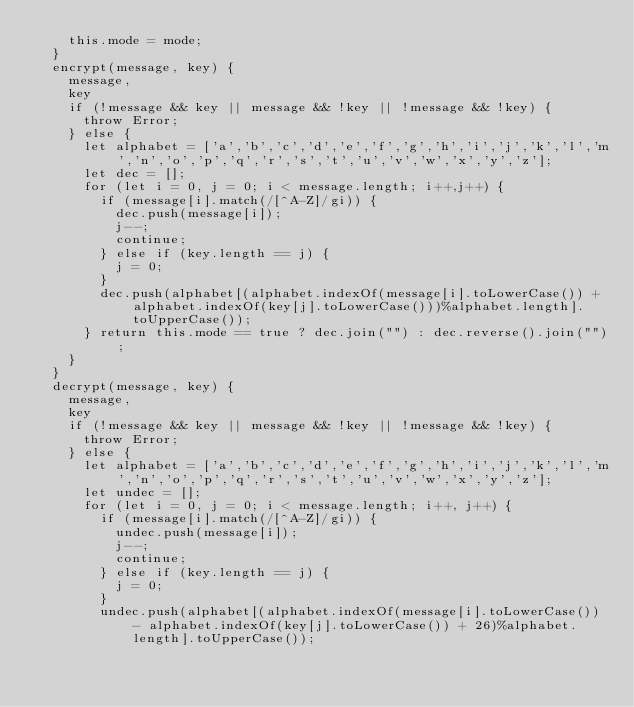Convert code to text. <code><loc_0><loc_0><loc_500><loc_500><_JavaScript_>    this.mode = mode;
  }
  encrypt(message, key) {
    message,
    key
    if (!message && key || message && !key || !message && !key) {
      throw Error;
    } else {
      let alphabet = ['a','b','c','d','e','f','g','h','i','j','k','l','m','n','o','p','q','r','s','t','u','v','w','x','y','z'];
      let dec = [];
      for (let i = 0, j = 0; i < message.length; i++,j++) {
        if (message[i].match(/[^A-Z]/gi)) {
          dec.push(message[i]);
          j--;
          continue;
        } else if (key.length == j) {
          j = 0;
        }
        dec.push(alphabet[(alphabet.indexOf(message[i].toLowerCase()) + alphabet.indexOf(key[j].toLowerCase()))%alphabet.length].toUpperCase());
      } return this.mode == true ? dec.join("") : dec.reverse().join("");
    } 
  }   
  decrypt(message, key) {
    message,
    key
    if (!message && key || message && !key || !message && !key) {
      throw Error;
    } else {
      let alphabet = ['a','b','c','d','e','f','g','h','i','j','k','l','m','n','o','p','q','r','s','t','u','v','w','x','y','z'];
      let undec = [];
      for (let i = 0, j = 0; i < message.length; i++, j++) {
        if (message[i].match(/[^A-Z]/gi)) {
          undec.push(message[i]);
          j--;
          continue;
        } else if (key.length == j) {
          j = 0;
        }        
        undec.push(alphabet[(alphabet.indexOf(message[i].toLowerCase()) - alphabet.indexOf(key[j].toLowerCase()) + 26)%alphabet.length].toUpperCase());</code> 